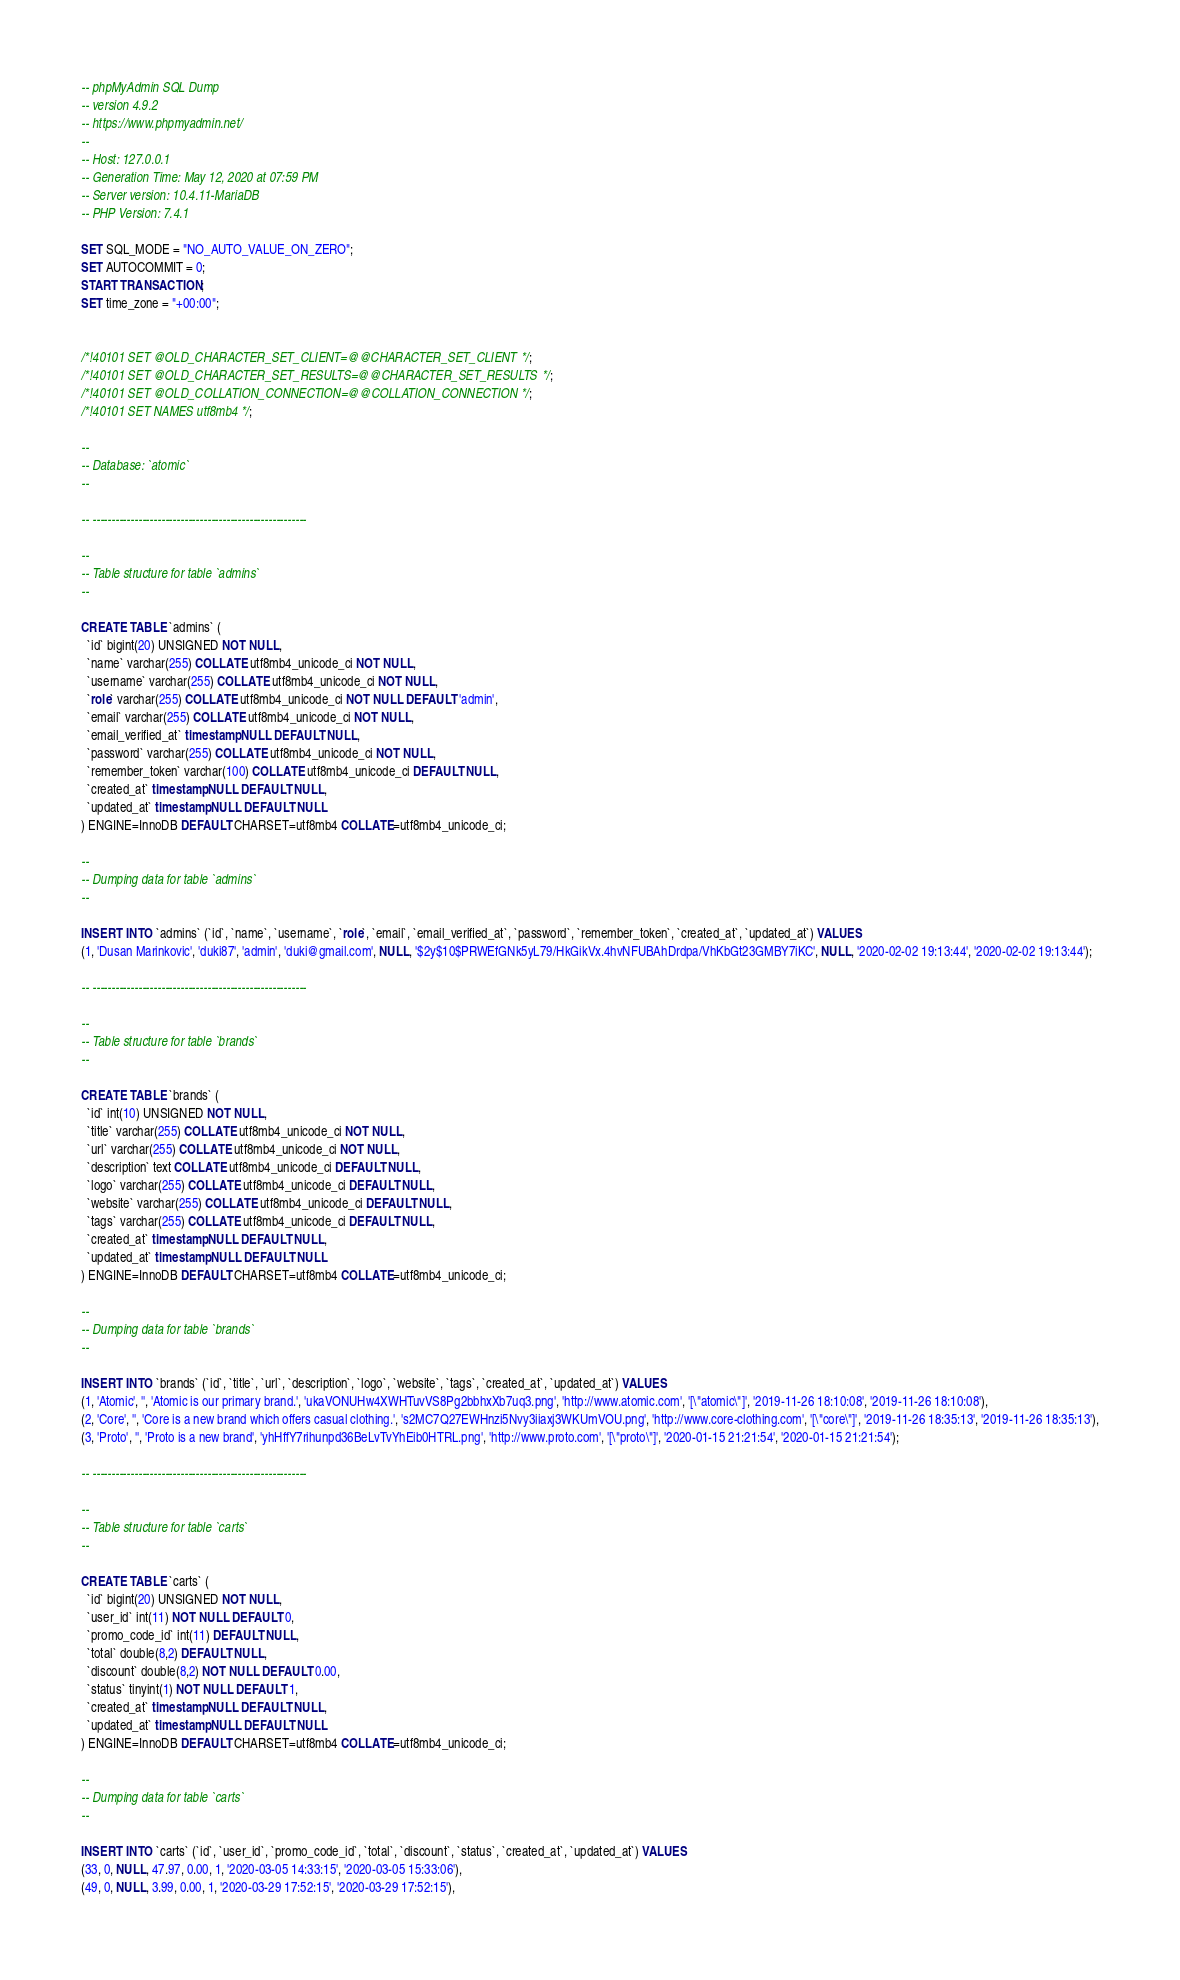<code> <loc_0><loc_0><loc_500><loc_500><_SQL_>-- phpMyAdmin SQL Dump
-- version 4.9.2
-- https://www.phpmyadmin.net/
--
-- Host: 127.0.0.1
-- Generation Time: May 12, 2020 at 07:59 PM
-- Server version: 10.4.11-MariaDB
-- PHP Version: 7.4.1

SET SQL_MODE = "NO_AUTO_VALUE_ON_ZERO";
SET AUTOCOMMIT = 0;
START TRANSACTION;
SET time_zone = "+00:00";


/*!40101 SET @OLD_CHARACTER_SET_CLIENT=@@CHARACTER_SET_CLIENT */;
/*!40101 SET @OLD_CHARACTER_SET_RESULTS=@@CHARACTER_SET_RESULTS */;
/*!40101 SET @OLD_COLLATION_CONNECTION=@@COLLATION_CONNECTION */;
/*!40101 SET NAMES utf8mb4 */;

--
-- Database: `atomic`
--

-- --------------------------------------------------------

--
-- Table structure for table `admins`
--

CREATE TABLE `admins` (
  `id` bigint(20) UNSIGNED NOT NULL,
  `name` varchar(255) COLLATE utf8mb4_unicode_ci NOT NULL,
  `username` varchar(255) COLLATE utf8mb4_unicode_ci NOT NULL,
  `role` varchar(255) COLLATE utf8mb4_unicode_ci NOT NULL DEFAULT 'admin',
  `email` varchar(255) COLLATE utf8mb4_unicode_ci NOT NULL,
  `email_verified_at` timestamp NULL DEFAULT NULL,
  `password` varchar(255) COLLATE utf8mb4_unicode_ci NOT NULL,
  `remember_token` varchar(100) COLLATE utf8mb4_unicode_ci DEFAULT NULL,
  `created_at` timestamp NULL DEFAULT NULL,
  `updated_at` timestamp NULL DEFAULT NULL
) ENGINE=InnoDB DEFAULT CHARSET=utf8mb4 COLLATE=utf8mb4_unicode_ci;

--
-- Dumping data for table `admins`
--

INSERT INTO `admins` (`id`, `name`, `username`, `role`, `email`, `email_verified_at`, `password`, `remember_token`, `created_at`, `updated_at`) VALUES
(1, 'Dusan Marinkovic', 'duki87', 'admin', 'duki@gmail.com', NULL, '$2y$10$PRWEfGNk5yL79/HkGikVx.4hvNFUBAhDrdpa/VhKbGt23GMBY7iKC', NULL, '2020-02-02 19:13:44', '2020-02-02 19:13:44');

-- --------------------------------------------------------

--
-- Table structure for table `brands`
--

CREATE TABLE `brands` (
  `id` int(10) UNSIGNED NOT NULL,
  `title` varchar(255) COLLATE utf8mb4_unicode_ci NOT NULL,
  `url` varchar(255) COLLATE utf8mb4_unicode_ci NOT NULL,
  `description` text COLLATE utf8mb4_unicode_ci DEFAULT NULL,
  `logo` varchar(255) COLLATE utf8mb4_unicode_ci DEFAULT NULL,
  `website` varchar(255) COLLATE utf8mb4_unicode_ci DEFAULT NULL,
  `tags` varchar(255) COLLATE utf8mb4_unicode_ci DEFAULT NULL,
  `created_at` timestamp NULL DEFAULT NULL,
  `updated_at` timestamp NULL DEFAULT NULL
) ENGINE=InnoDB DEFAULT CHARSET=utf8mb4 COLLATE=utf8mb4_unicode_ci;

--
-- Dumping data for table `brands`
--

INSERT INTO `brands` (`id`, `title`, `url`, `description`, `logo`, `website`, `tags`, `created_at`, `updated_at`) VALUES
(1, 'Atomic', '', 'Atomic is our primary brand.', 'ukaVONUHw4XWHTuvVS8Pg2bbhxXb7uq3.png', 'http://www.atomic.com', '[\"atomic\"]', '2019-11-26 18:10:08', '2019-11-26 18:10:08'),
(2, 'Core', '', 'Core is a new brand which offers casual clothing.', 's2MC7Q27EWHnzi5Nvy3iiaxj3WKUmVOU.png', 'http://www.core-clothing.com', '[\"core\"]', '2019-11-26 18:35:13', '2019-11-26 18:35:13'),
(3, 'Proto', '', 'Proto is a new brand', 'yhHffY7rihunpd36BeLvTvYhEib0HTRL.png', 'http://www.proto.com', '[\"proto\"]', '2020-01-15 21:21:54', '2020-01-15 21:21:54');

-- --------------------------------------------------------

--
-- Table structure for table `carts`
--

CREATE TABLE `carts` (
  `id` bigint(20) UNSIGNED NOT NULL,
  `user_id` int(11) NOT NULL DEFAULT 0,
  `promo_code_id` int(11) DEFAULT NULL,
  `total` double(8,2) DEFAULT NULL,
  `discount` double(8,2) NOT NULL DEFAULT 0.00,
  `status` tinyint(1) NOT NULL DEFAULT 1,
  `created_at` timestamp NULL DEFAULT NULL,
  `updated_at` timestamp NULL DEFAULT NULL
) ENGINE=InnoDB DEFAULT CHARSET=utf8mb4 COLLATE=utf8mb4_unicode_ci;

--
-- Dumping data for table `carts`
--

INSERT INTO `carts` (`id`, `user_id`, `promo_code_id`, `total`, `discount`, `status`, `created_at`, `updated_at`) VALUES
(33, 0, NULL, 47.97, 0.00, 1, '2020-03-05 14:33:15', '2020-03-05 15:33:06'),
(49, 0, NULL, 3.99, 0.00, 1, '2020-03-29 17:52:15', '2020-03-29 17:52:15'),</code> 